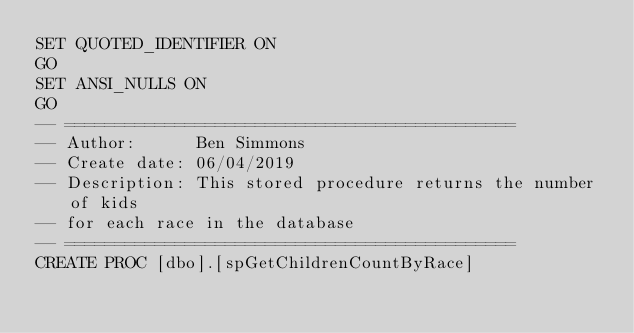<code> <loc_0><loc_0><loc_500><loc_500><_SQL_>SET QUOTED_IDENTIFIER ON
GO
SET ANSI_NULLS ON
GO
-- =============================================
-- Author:		Ben Simmons
-- Create date: 06/04/2019
-- Description:	This stored procedure returns the number of kids
-- for each race in the database
-- =============================================
CREATE PROC [dbo].[spGetChildrenCountByRace] </code> 